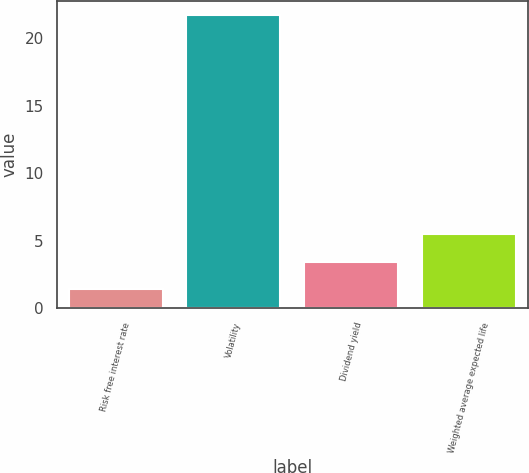Convert chart to OTSL. <chart><loc_0><loc_0><loc_500><loc_500><bar_chart><fcel>Risk free interest rate<fcel>Volatility<fcel>Dividend yield<fcel>Weighted average expected life<nl><fcel>1.4<fcel>21.7<fcel>3.43<fcel>5.46<nl></chart> 